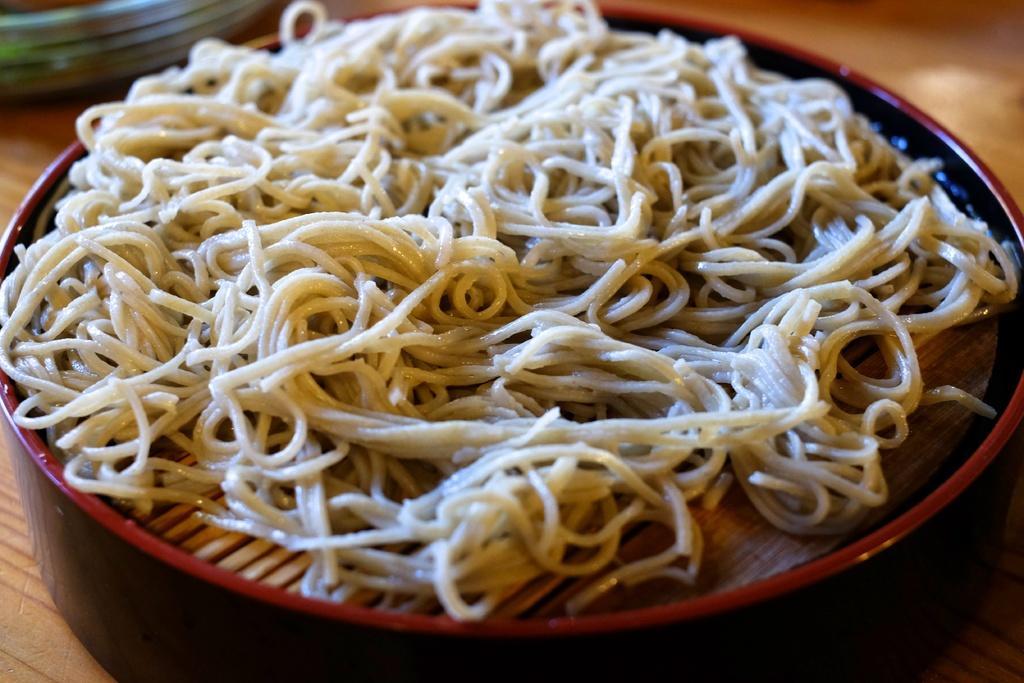How would you summarize this image in a sentence or two? In this image I can see the bowl with food. To the side I can see some objects,. These are on the brown color surface. 